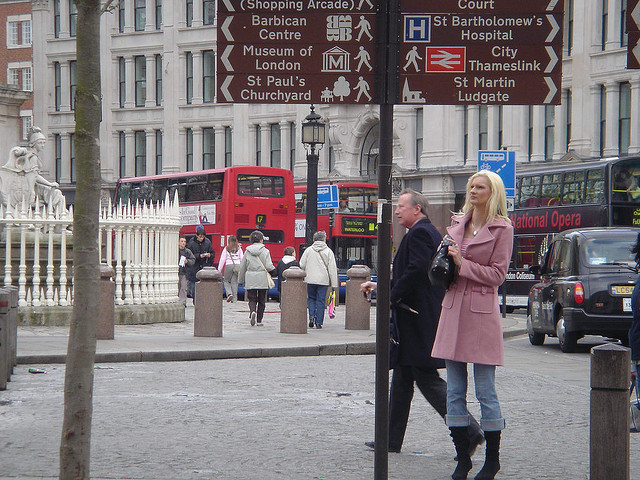<image>What vehicle is behind the fence? I am not sure what vehicle is behind the fence. The answer can be either none or a bus. What does the red sign say? I am not sure what the red sign says. It could say 'opera', 'city thameslink', 'city', 'arrows', 'city thames tink', or 'train'. What color laces is on the girl's boots? It is ambiguous what color laces is on the girl's boots. There might be no laces. What vehicle is behind the fence? There is a bus behind the fence. What color laces is on the girl's boots? There are black laces on the girl's boots. What does the red sign say? I am not sure what the red sign says. It can be seen 'opera', 'city thameslink', 'city', 'arrows', 'train' or 'symbol'. 